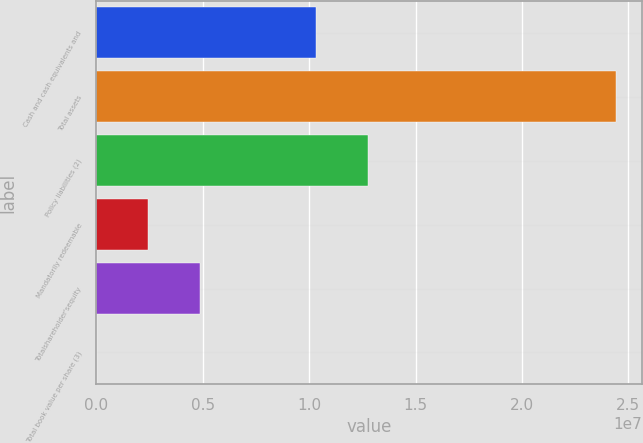<chart> <loc_0><loc_0><loc_500><loc_500><bar_chart><fcel>Cash and cash equivalents and<fcel>Total assets<fcel>Policy liabilities (2)<fcel>Mandatorily redeemable<fcel>Totalshareholder'sequity<fcel>Total book value per share (3)<nl><fcel>1.03191e+07<fcel>2.44314e+07<fcel>1.27623e+07<fcel>2.44317e+06<fcel>4.88631e+06<fcel>31.61<nl></chart> 